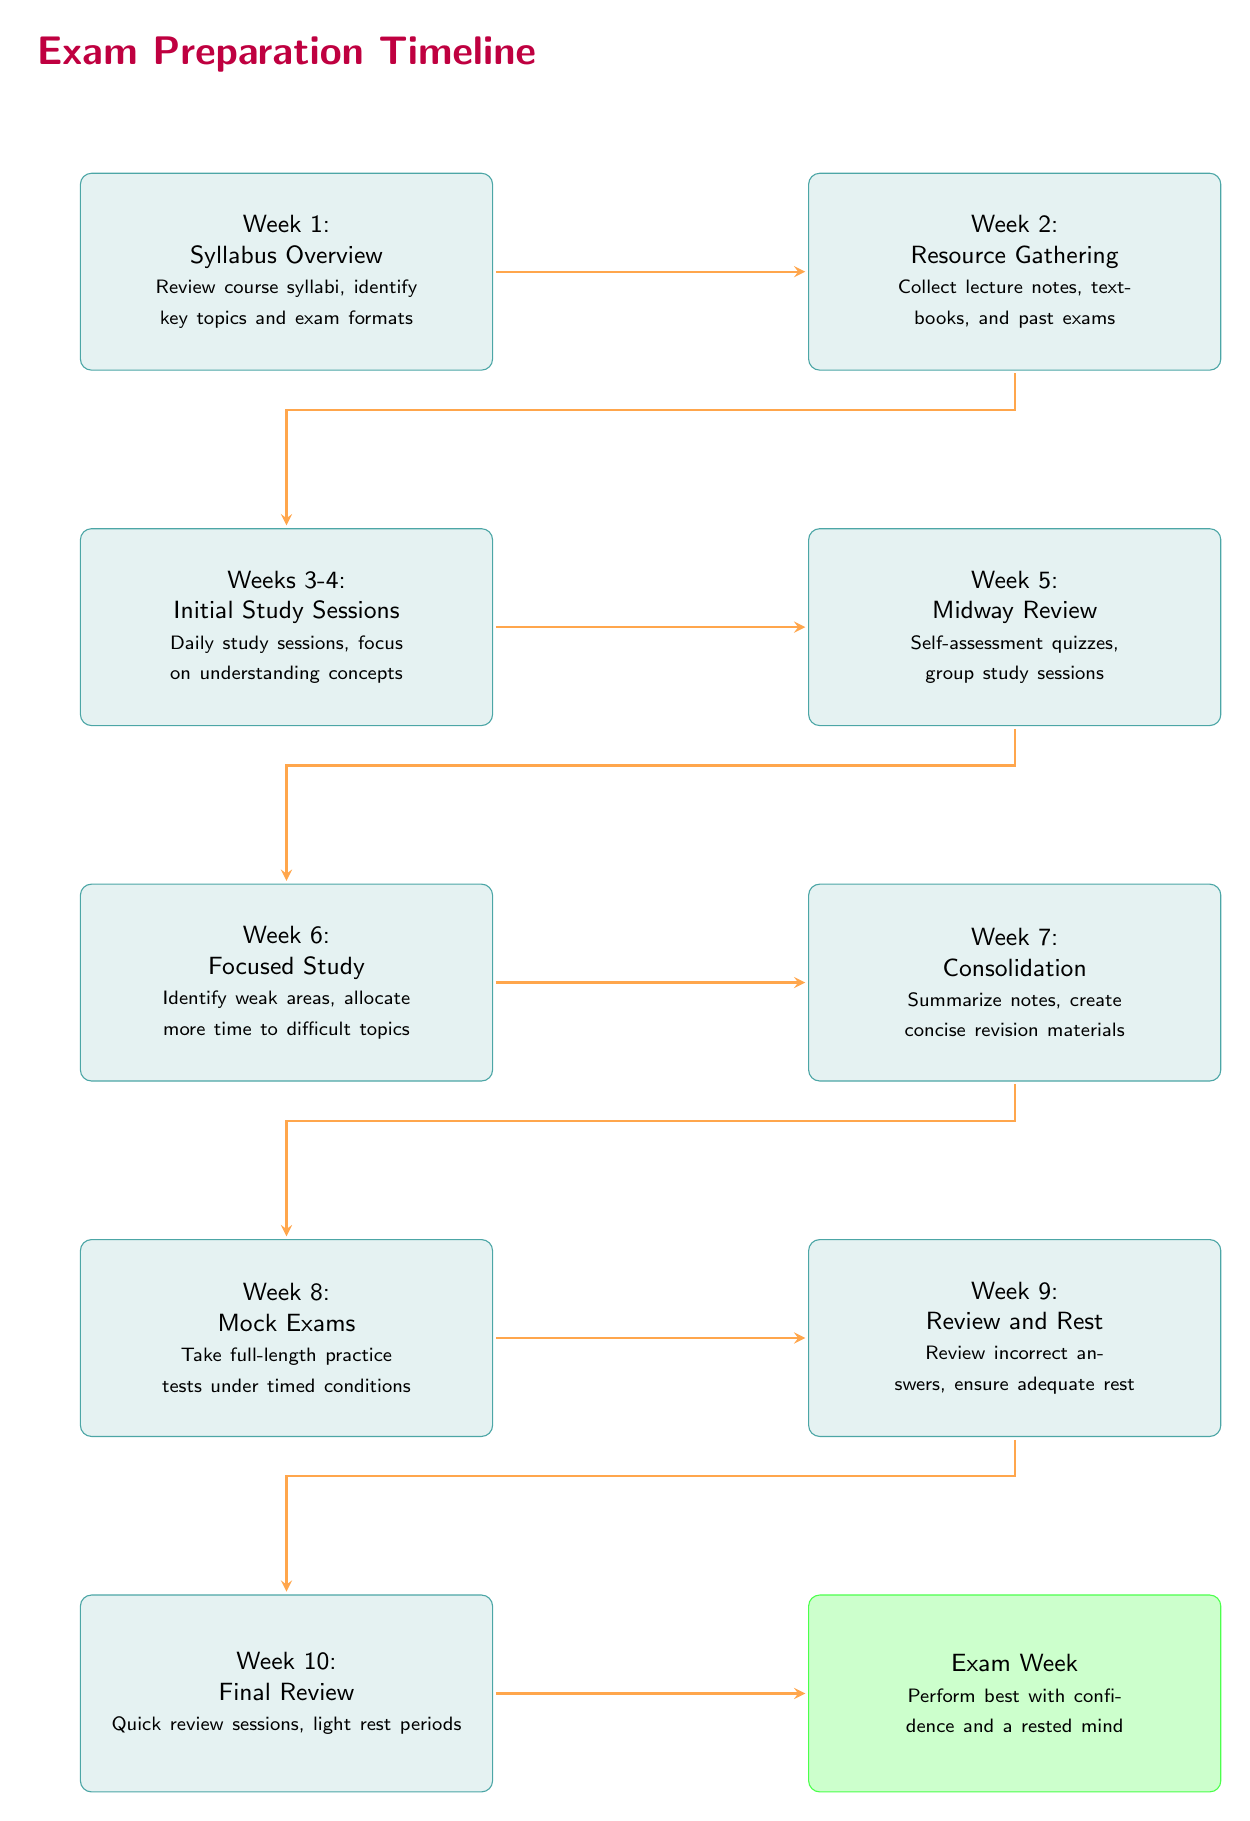What is the focus of Week 2? The diagram indicates that Week 2 is dedicated to gathering resources, specifically mentioning collecting lecture notes, textbooks, and past exams.
Answer: Resource Gathering How many weeks are designated for Initial Study Sessions? The diagram specifies that Initial Study Sessions take place over two weeks, specifically Weeks 3 and 4.
Answer: 2 weeks What key activity occurs during Week 6? According to the diagram, Week 6 emphasizes focused study where students identify weak areas and allocate more time to difficult topics.
Answer: Focused Study What happens in Week 9? The diagram notes that during Week 9, students review incorrect answers from their mock exams and ensure they get adequate rest.
Answer: Review and Rest What is the final activity before the exam week? According to the structure of the diagram, the final review sessions and light rest periods take place in Week 10, right before the exam week.
Answer: Final Review What is the purpose of the arrow connecting Week 8 to Week 9? The arrow implies a progression from taking mock exams in Week 8 to the subsequent activity of reviewing and resting in Week 9, creating a flow between these key steps.
Answer: Transition Which week focuses on self-assessment? Week 5 is clearly indicated in the diagram as the time for midway review through self-assessment quizzes and group study sessions.
Answer: Week 5 What color represents the Exam Week? The diagram illustrates Exam Week with a distinct green color, setting it apart from the other weeks.
Answer: Green How many activities are specified between Week 1 and Exam Week? By following the diagram from Week 1 through to Exam Week, we can count a total of ten distinct activities outlined in the timeline.
Answer: 10 activities 